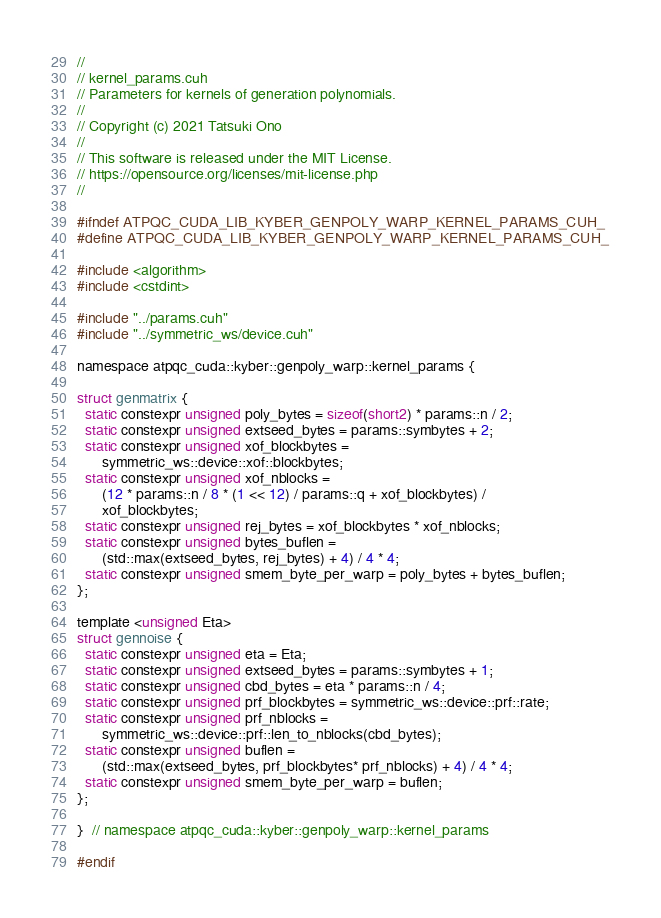<code> <loc_0><loc_0><loc_500><loc_500><_Cuda_>//
// kernel_params.cuh
// Parameters for kernels of generation polynomials.
//
// Copyright (c) 2021 Tatsuki Ono
//
// This software is released under the MIT License.
// https://opensource.org/licenses/mit-license.php
//

#ifndef ATPQC_CUDA_LIB_KYBER_GENPOLY_WARP_KERNEL_PARAMS_CUH_
#define ATPQC_CUDA_LIB_KYBER_GENPOLY_WARP_KERNEL_PARAMS_CUH_

#include <algorithm>
#include <cstdint>

#include "../params.cuh"
#include "../symmetric_ws/device.cuh"

namespace atpqc_cuda::kyber::genpoly_warp::kernel_params {

struct genmatrix {
  static constexpr unsigned poly_bytes = sizeof(short2) * params::n / 2;
  static constexpr unsigned extseed_bytes = params::symbytes + 2;
  static constexpr unsigned xof_blockbytes =
      symmetric_ws::device::xof::blockbytes;
  static constexpr unsigned xof_nblocks =
      (12 * params::n / 8 * (1 << 12) / params::q + xof_blockbytes) /
      xof_blockbytes;
  static constexpr unsigned rej_bytes = xof_blockbytes * xof_nblocks;
  static constexpr unsigned bytes_buflen =
      (std::max(extseed_bytes, rej_bytes) + 4) / 4 * 4;
  static constexpr unsigned smem_byte_per_warp = poly_bytes + bytes_buflen;
};

template <unsigned Eta>
struct gennoise {
  static constexpr unsigned eta = Eta;
  static constexpr unsigned extseed_bytes = params::symbytes + 1;
  static constexpr unsigned cbd_bytes = eta * params::n / 4;
  static constexpr unsigned prf_blockbytes = symmetric_ws::device::prf::rate;
  static constexpr unsigned prf_nblocks =
      symmetric_ws::device::prf::len_to_nblocks(cbd_bytes);
  static constexpr unsigned buflen =
      (std::max(extseed_bytes, prf_blockbytes* prf_nblocks) + 4) / 4 * 4;
  static constexpr unsigned smem_byte_per_warp = buflen;
};

}  // namespace atpqc_cuda::kyber::genpoly_warp::kernel_params

#endif
</code> 